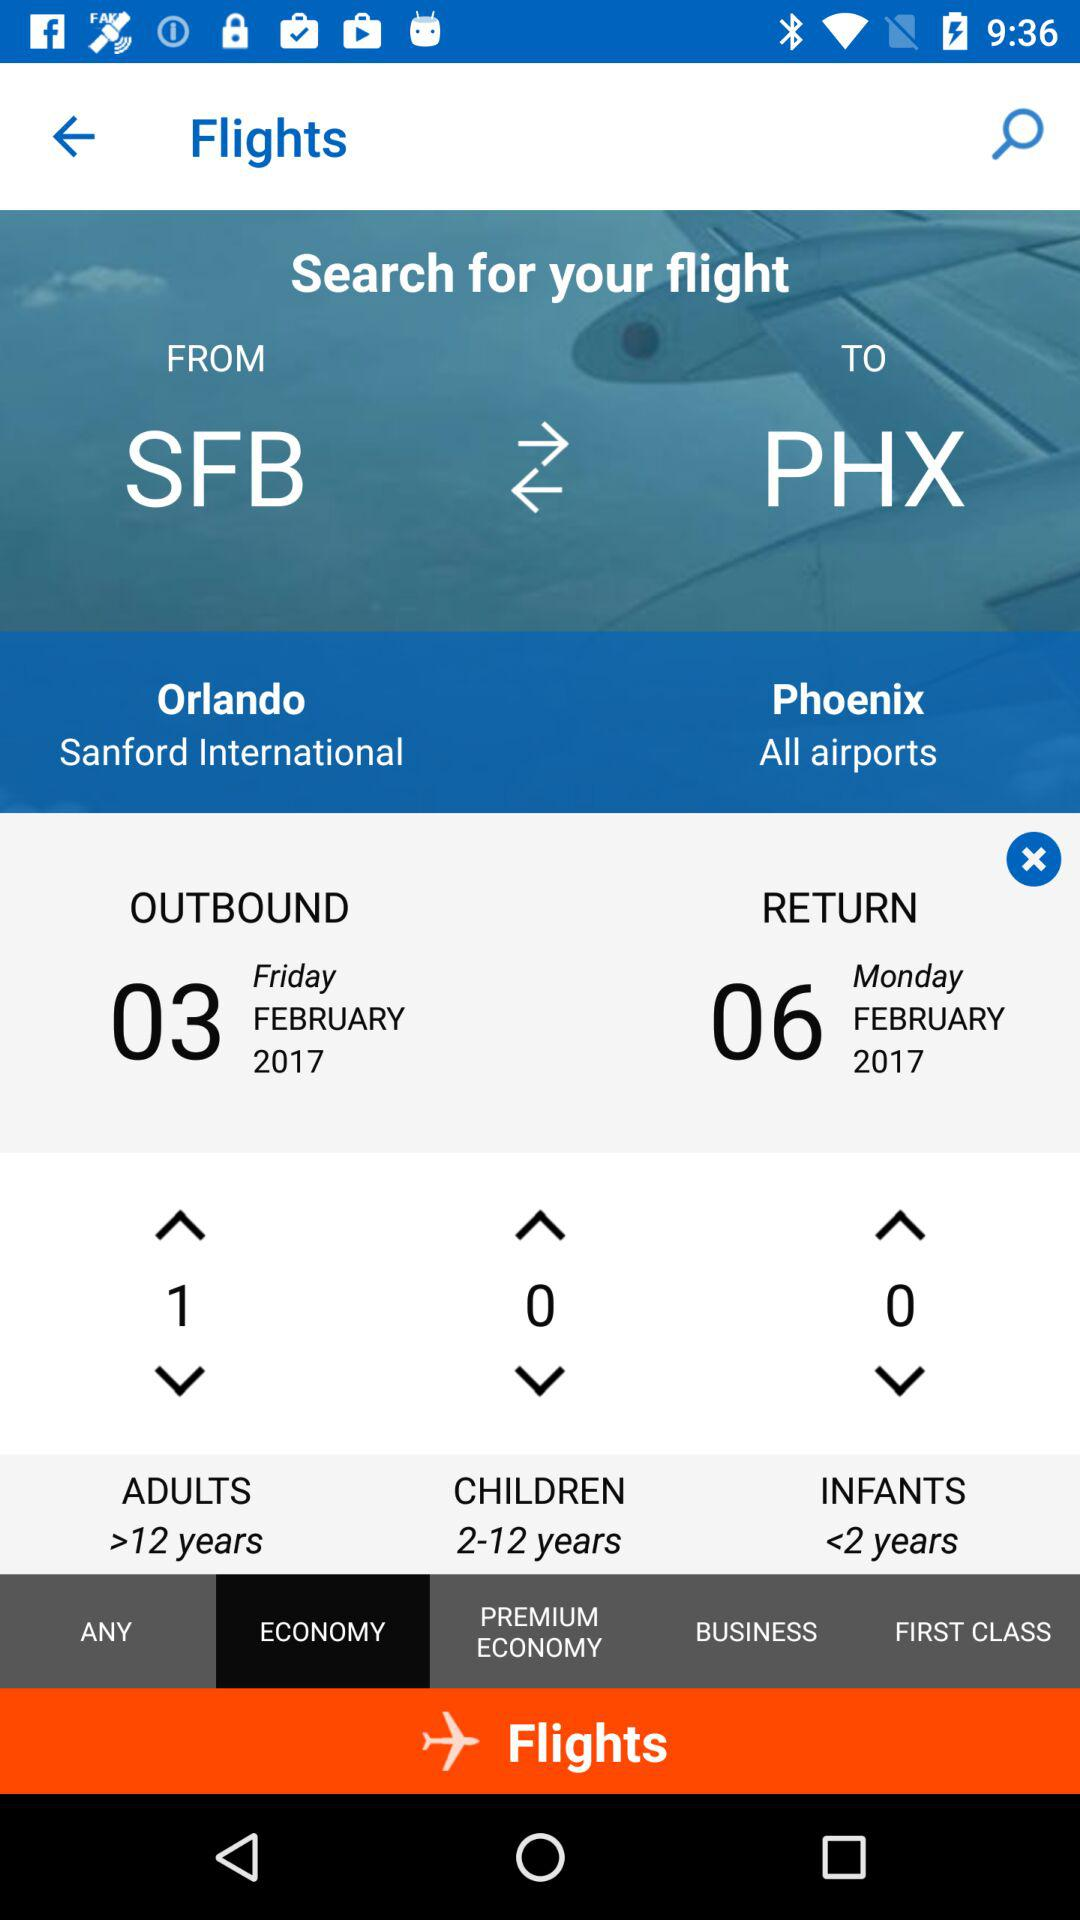Which seating option is selected? The selected seating option is "ECONOMY". 